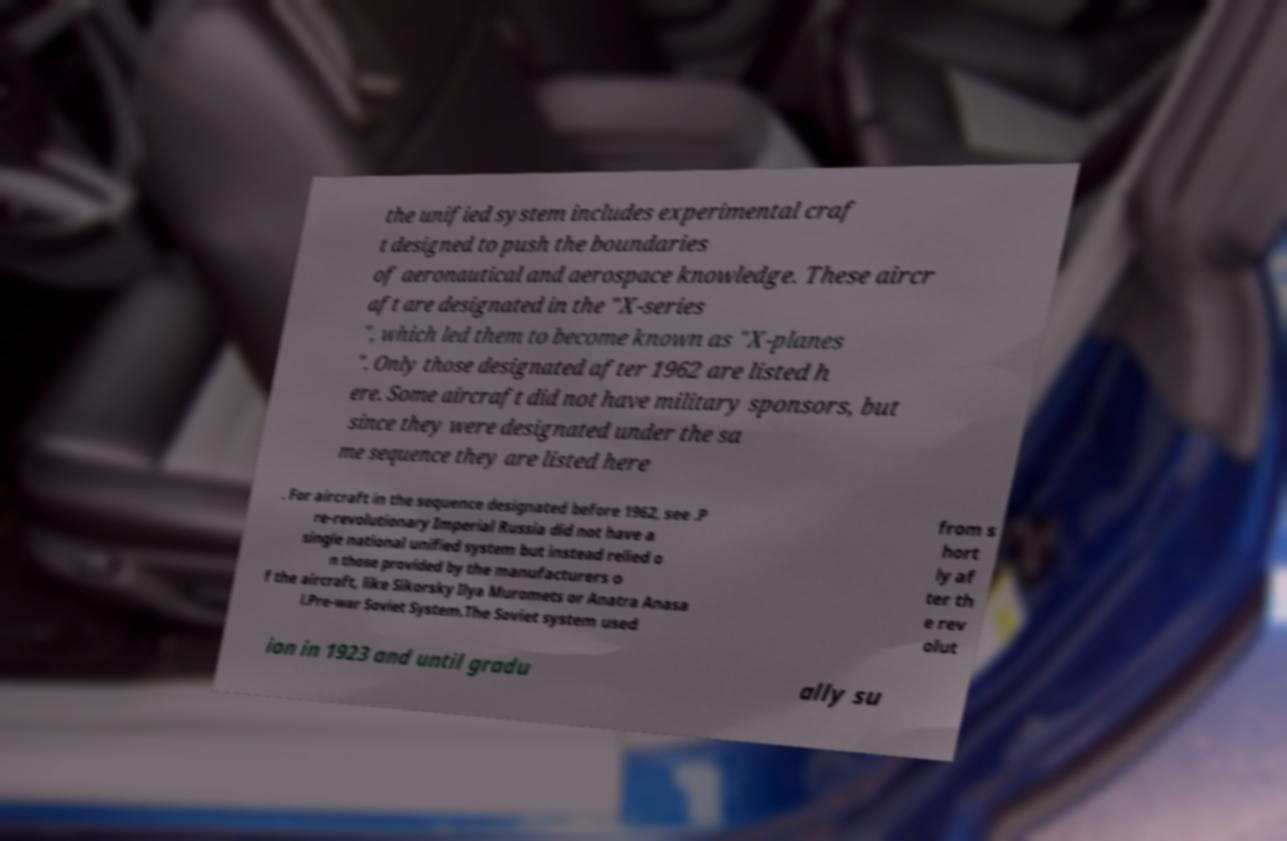Please read and relay the text visible in this image. What does it say? the unified system includes experimental craf t designed to push the boundaries of aeronautical and aerospace knowledge. These aircr aft are designated in the "X-series ", which led them to become known as "X-planes ". Only those designated after 1962 are listed h ere. Some aircraft did not have military sponsors, but since they were designated under the sa me sequence they are listed here . For aircraft in the sequence designated before 1962, see .P re-revolutionary Imperial Russia did not have a single national unified system but instead relied o n those provided by the manufacturers o f the aircraft, like Sikorsky Ilya Muromets or Anatra Anasa l.Pre-war Soviet System.The Soviet system used from s hort ly af ter th e rev olut ion in 1923 and until gradu ally su 